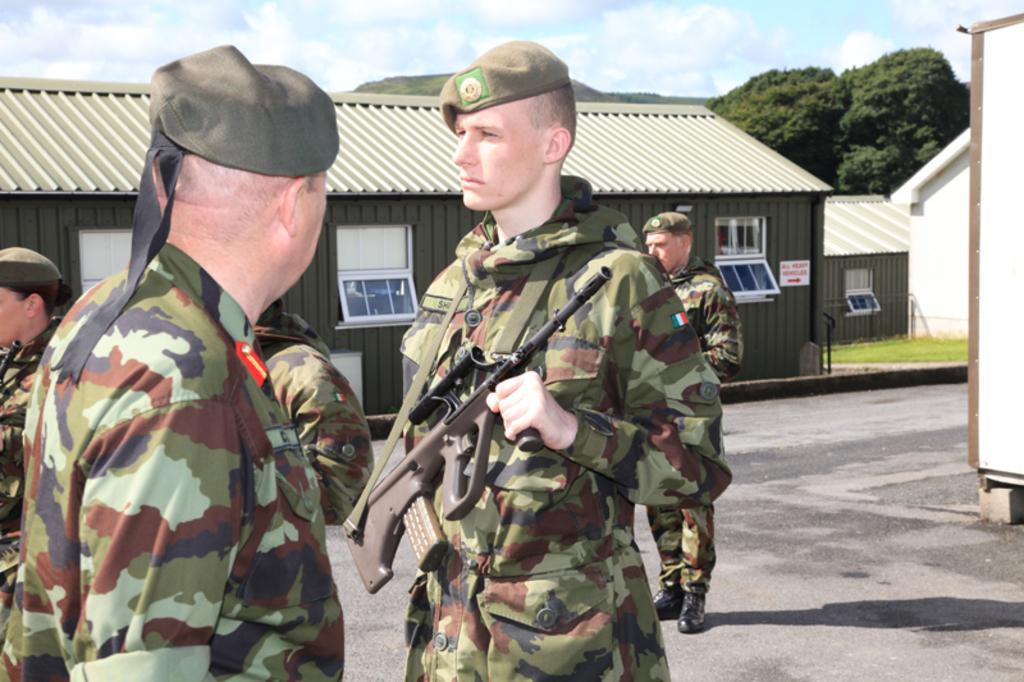Could you give a brief overview of what you see in this image? In this image we can see some soldiers holding weapons such as guns. In the background, we can see the sheds. We can see the grass and surrounding trees. At the top we can see the clouds in the sky. 